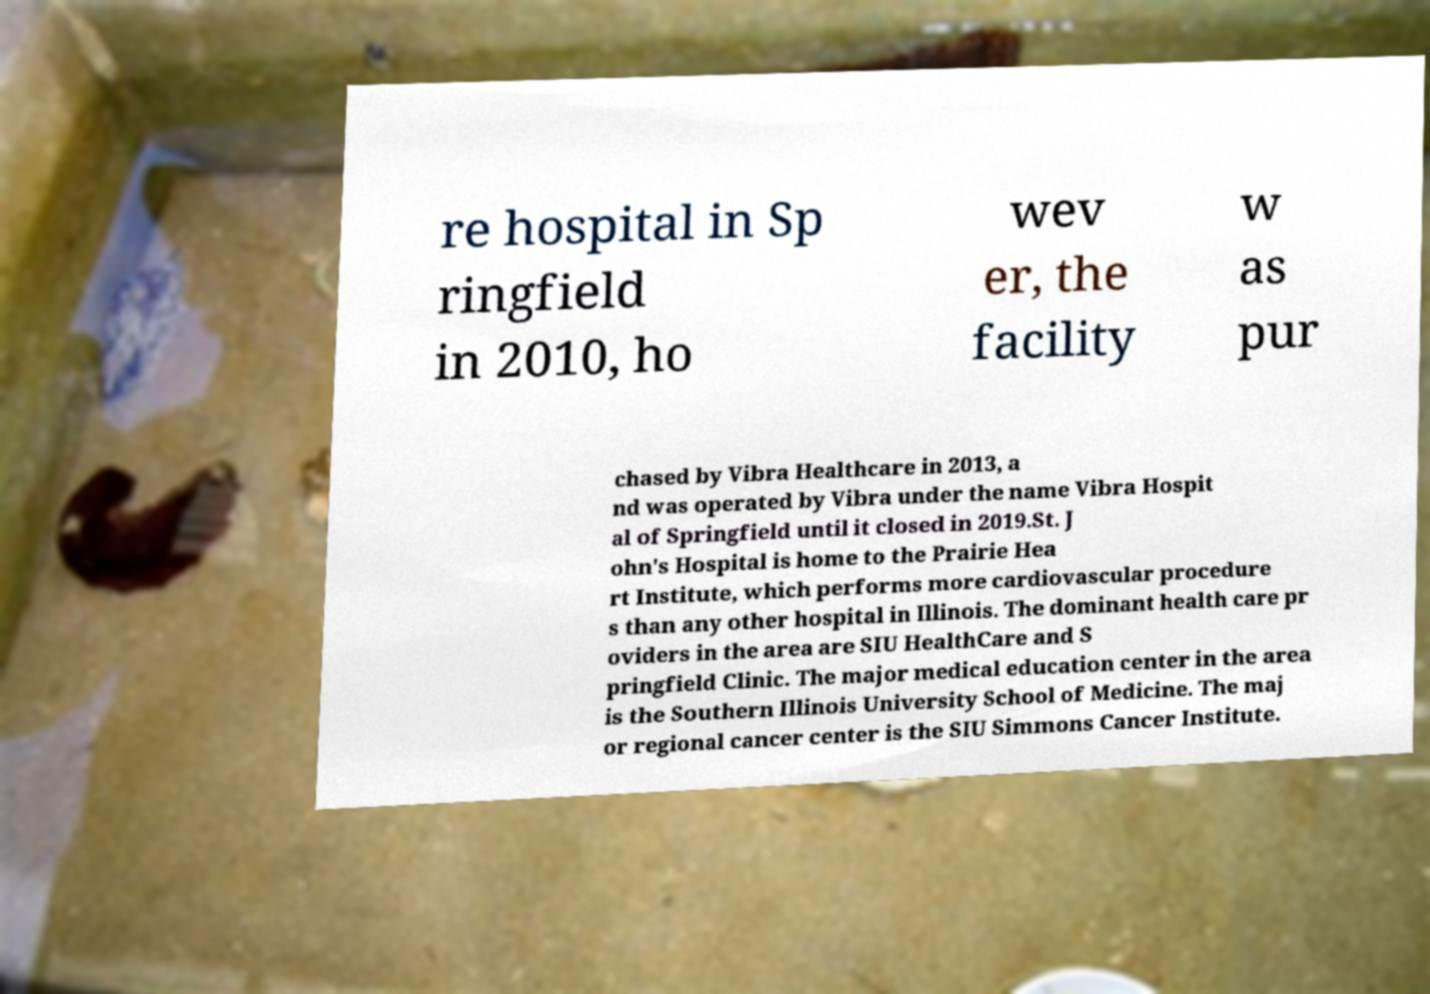What messages or text are displayed in this image? I need them in a readable, typed format. re hospital in Sp ringfield in 2010, ho wev er, the facility w as pur chased by Vibra Healthcare in 2013, a nd was operated by Vibra under the name Vibra Hospit al of Springfield until it closed in 2019.St. J ohn's Hospital is home to the Prairie Hea rt Institute, which performs more cardiovascular procedure s than any other hospital in Illinois. The dominant health care pr oviders in the area are SIU HealthCare and S pringfield Clinic. The major medical education center in the area is the Southern Illinois University School of Medicine. The maj or regional cancer center is the SIU Simmons Cancer Institute. 